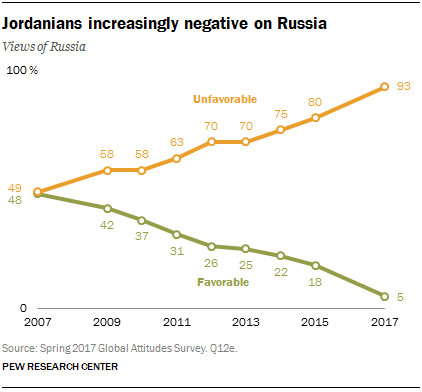Specify some key components in this picture. The satisfied rate has been over 25 for 5 times. The unfavorable line reached its peak in 2017. 